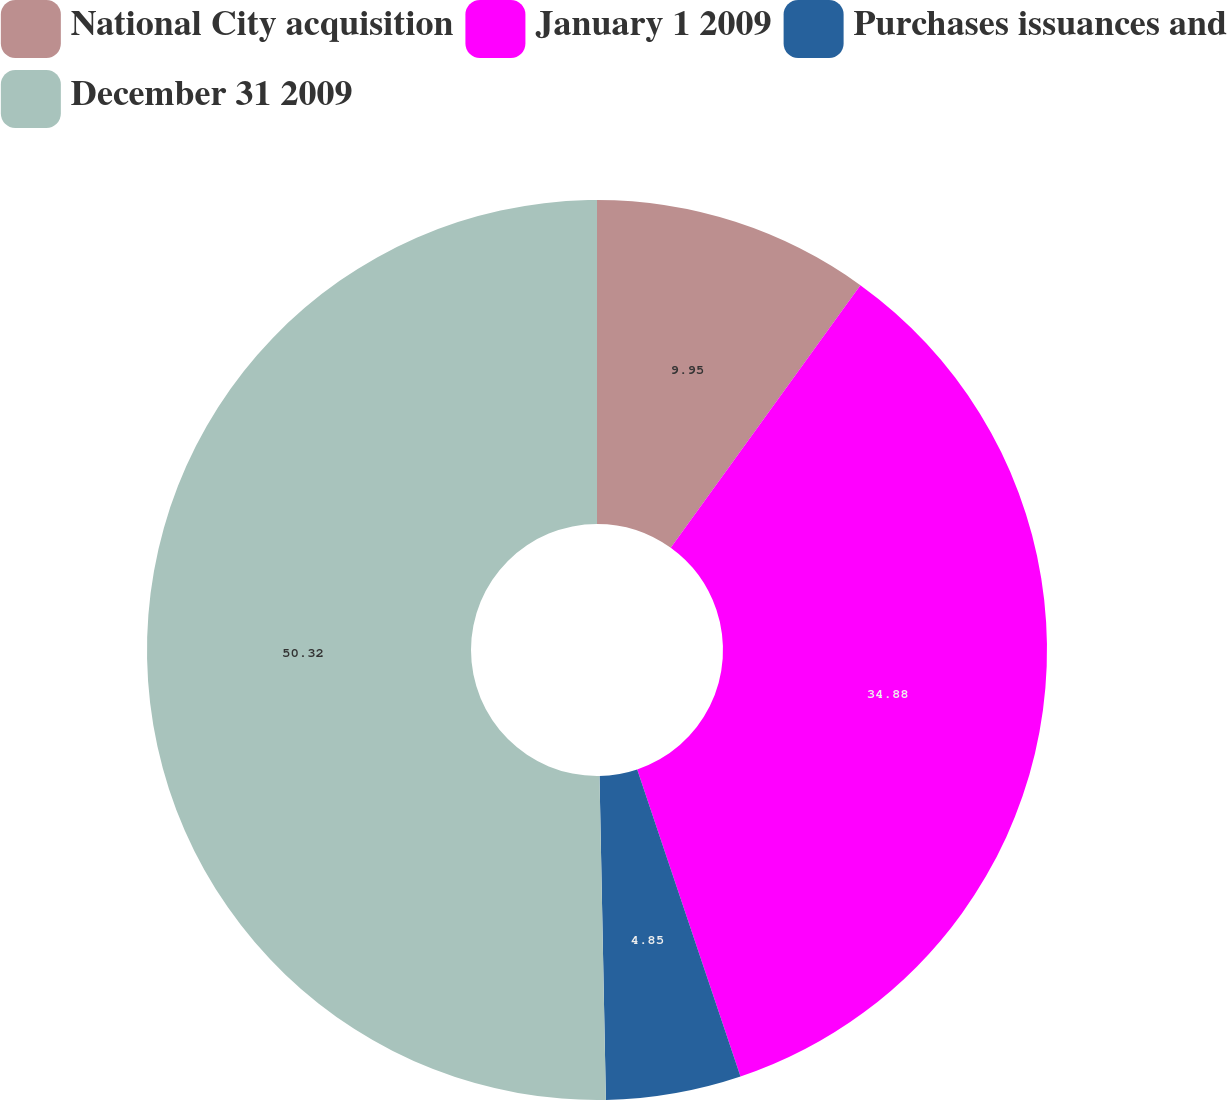Convert chart. <chart><loc_0><loc_0><loc_500><loc_500><pie_chart><fcel>National City acquisition<fcel>January 1 2009<fcel>Purchases issuances and<fcel>December 31 2009<nl><fcel>9.95%<fcel>34.88%<fcel>4.85%<fcel>50.31%<nl></chart> 